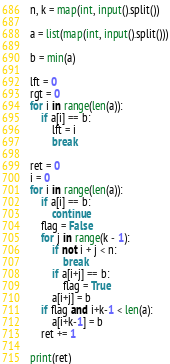<code> <loc_0><loc_0><loc_500><loc_500><_Python_>n, k = map(int, input().split())

a = list(map(int, input().split()))

b = min(a)

lft = 0
rgt = 0
for i in range(len(a)):
    if a[i] == b:
        lft = i
        break

ret = 0
i = 0
for i in range(len(a)):
    if a[i] == b:
        continue
    flag = False
    for j in range(k - 1):
        if not i + j < n:
            break
        if a[i+j] == b:
            flag = True
        a[i+j] = b
    if flag and i+k-1 < len(a):
        a[i+k-1] = b
    ret += 1

print(ret)</code> 